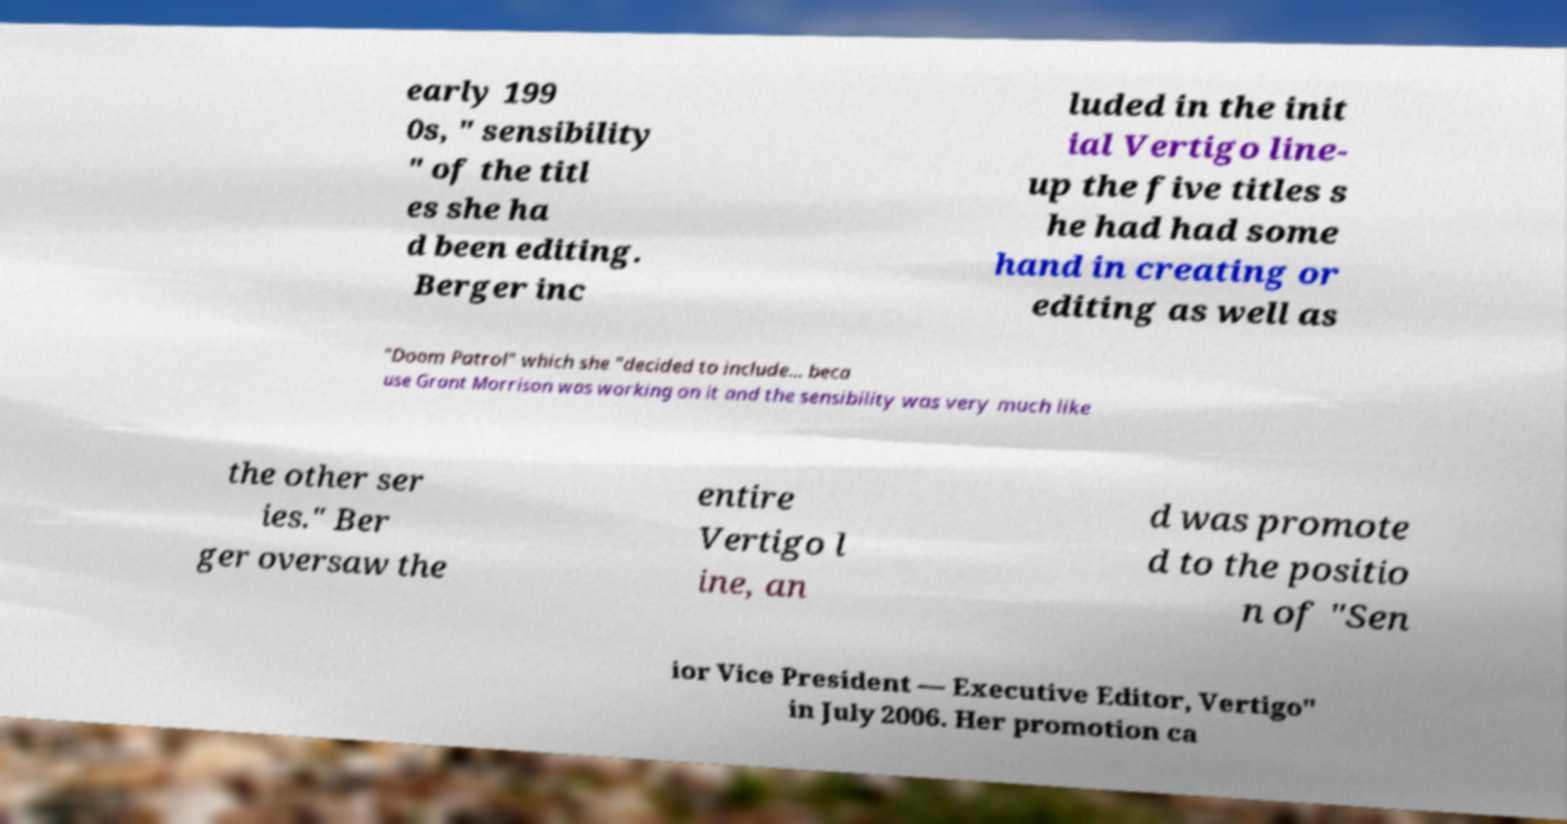Can you accurately transcribe the text from the provided image for me? early 199 0s, " sensibility " of the titl es she ha d been editing. Berger inc luded in the init ial Vertigo line- up the five titles s he had had some hand in creating or editing as well as "Doom Patrol" which she "decided to include... beca use Grant Morrison was working on it and the sensibility was very much like the other ser ies." Ber ger oversaw the entire Vertigo l ine, an d was promote d to the positio n of "Sen ior Vice President — Executive Editor, Vertigo" in July 2006. Her promotion ca 